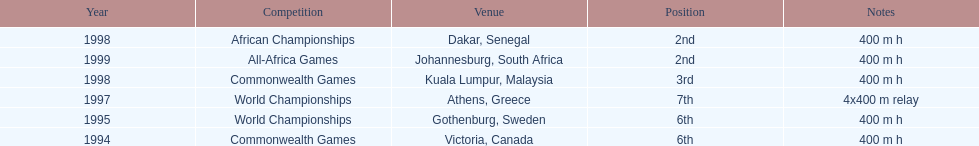Other than 1999, what year did ken harnden win second place? 1998. 